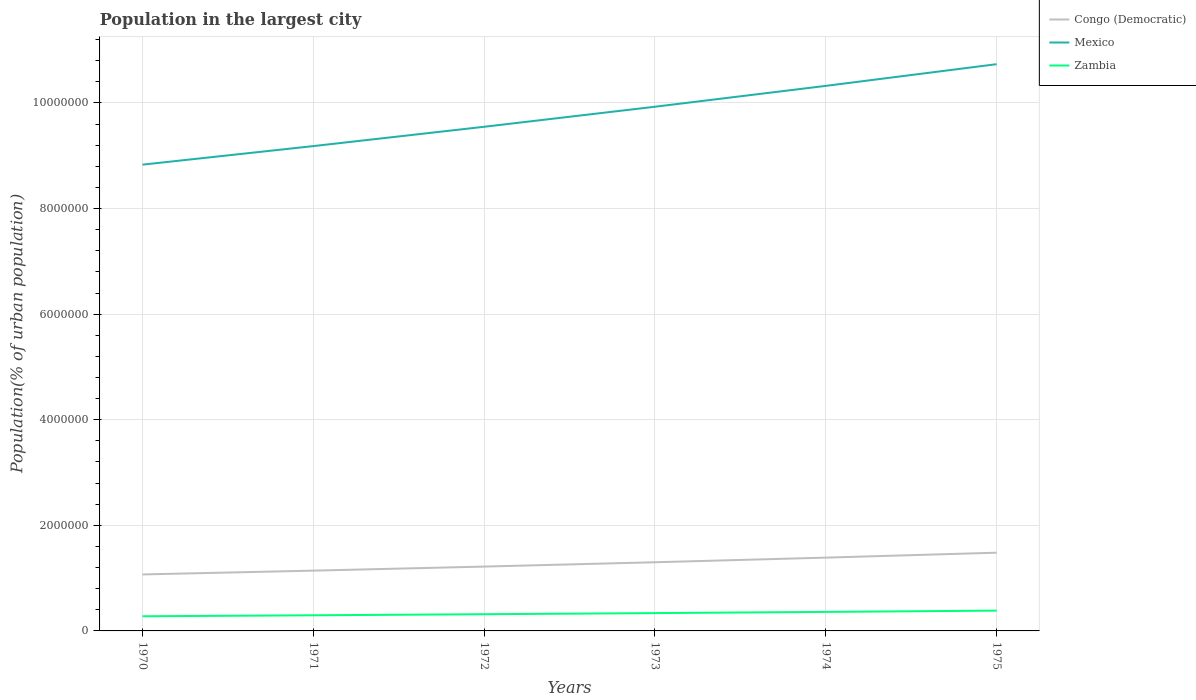Does the line corresponding to Mexico intersect with the line corresponding to Zambia?
Provide a short and direct response. No. Is the number of lines equal to the number of legend labels?
Your answer should be very brief. Yes. Across all years, what is the maximum population in the largest city in Congo (Democratic)?
Offer a terse response. 1.07e+06. In which year was the population in the largest city in Zambia maximum?
Provide a succinct answer. 1970. What is the total population in the largest city in Mexico in the graph?
Ensure brevity in your answer.  -8.06e+05. What is the difference between the highest and the second highest population in the largest city in Mexico?
Your response must be concise. 1.90e+06. What is the difference between the highest and the lowest population in the largest city in Congo (Democratic)?
Keep it short and to the point. 3. Is the population in the largest city in Mexico strictly greater than the population in the largest city in Zambia over the years?
Offer a terse response. No. How many lines are there?
Ensure brevity in your answer.  3. Does the graph contain any zero values?
Provide a short and direct response. No. Where does the legend appear in the graph?
Provide a succinct answer. Top right. How are the legend labels stacked?
Ensure brevity in your answer.  Vertical. What is the title of the graph?
Provide a succinct answer. Population in the largest city. What is the label or title of the X-axis?
Provide a succinct answer. Years. What is the label or title of the Y-axis?
Give a very brief answer. Population(% of urban population). What is the Population(% of urban population) in Congo (Democratic) in 1970?
Make the answer very short. 1.07e+06. What is the Population(% of urban population) of Mexico in 1970?
Your answer should be very brief. 8.83e+06. What is the Population(% of urban population) of Zambia in 1970?
Your response must be concise. 2.78e+05. What is the Population(% of urban population) of Congo (Democratic) in 1971?
Give a very brief answer. 1.14e+06. What is the Population(% of urban population) of Mexico in 1971?
Make the answer very short. 9.18e+06. What is the Population(% of urban population) of Zambia in 1971?
Offer a very short reply. 2.96e+05. What is the Population(% of urban population) of Congo (Democratic) in 1972?
Give a very brief answer. 1.22e+06. What is the Population(% of urban population) in Mexico in 1972?
Your answer should be very brief. 9.55e+06. What is the Population(% of urban population) in Zambia in 1972?
Provide a short and direct response. 3.16e+05. What is the Population(% of urban population) in Congo (Democratic) in 1973?
Keep it short and to the point. 1.30e+06. What is the Population(% of urban population) in Mexico in 1973?
Provide a short and direct response. 9.93e+06. What is the Population(% of urban population) of Zambia in 1973?
Your answer should be very brief. 3.38e+05. What is the Population(% of urban population) in Congo (Democratic) in 1974?
Your answer should be compact. 1.39e+06. What is the Population(% of urban population) in Mexico in 1974?
Make the answer very short. 1.03e+07. What is the Population(% of urban population) in Zambia in 1974?
Offer a terse response. 3.60e+05. What is the Population(% of urban population) in Congo (Democratic) in 1975?
Your response must be concise. 1.48e+06. What is the Population(% of urban population) in Mexico in 1975?
Keep it short and to the point. 1.07e+07. What is the Population(% of urban population) in Zambia in 1975?
Provide a short and direct response. 3.85e+05. Across all years, what is the maximum Population(% of urban population) of Congo (Democratic)?
Provide a succinct answer. 1.48e+06. Across all years, what is the maximum Population(% of urban population) in Mexico?
Your answer should be compact. 1.07e+07. Across all years, what is the maximum Population(% of urban population) in Zambia?
Provide a succinct answer. 3.85e+05. Across all years, what is the minimum Population(% of urban population) of Congo (Democratic)?
Provide a short and direct response. 1.07e+06. Across all years, what is the minimum Population(% of urban population) in Mexico?
Your response must be concise. 8.83e+06. Across all years, what is the minimum Population(% of urban population) in Zambia?
Provide a succinct answer. 2.78e+05. What is the total Population(% of urban population) in Congo (Democratic) in the graph?
Keep it short and to the point. 7.60e+06. What is the total Population(% of urban population) in Mexico in the graph?
Your answer should be compact. 5.85e+07. What is the total Population(% of urban population) of Zambia in the graph?
Provide a succinct answer. 1.97e+06. What is the difference between the Population(% of urban population) in Congo (Democratic) in 1970 and that in 1971?
Ensure brevity in your answer.  -7.20e+04. What is the difference between the Population(% of urban population) in Mexico in 1970 and that in 1971?
Keep it short and to the point. -3.51e+05. What is the difference between the Population(% of urban population) in Zambia in 1970 and that in 1971?
Provide a succinct answer. -1.87e+04. What is the difference between the Population(% of urban population) in Congo (Democratic) in 1970 and that in 1972?
Ensure brevity in your answer.  -1.49e+05. What is the difference between the Population(% of urban population) of Mexico in 1970 and that in 1972?
Provide a short and direct response. -7.17e+05. What is the difference between the Population(% of urban population) in Zambia in 1970 and that in 1972?
Make the answer very short. -3.87e+04. What is the difference between the Population(% of urban population) in Congo (Democratic) in 1970 and that in 1973?
Ensure brevity in your answer.  -2.31e+05. What is the difference between the Population(% of urban population) of Mexico in 1970 and that in 1973?
Offer a very short reply. -1.10e+06. What is the difference between the Population(% of urban population) of Zambia in 1970 and that in 1973?
Keep it short and to the point. -6.00e+04. What is the difference between the Population(% of urban population) in Congo (Democratic) in 1970 and that in 1974?
Ensure brevity in your answer.  -3.19e+05. What is the difference between the Population(% of urban population) of Mexico in 1970 and that in 1974?
Offer a very short reply. -1.49e+06. What is the difference between the Population(% of urban population) in Zambia in 1970 and that in 1974?
Ensure brevity in your answer.  -8.27e+04. What is the difference between the Population(% of urban population) in Congo (Democratic) in 1970 and that in 1975?
Offer a very short reply. -4.12e+05. What is the difference between the Population(% of urban population) in Mexico in 1970 and that in 1975?
Make the answer very short. -1.90e+06. What is the difference between the Population(% of urban population) in Zambia in 1970 and that in 1975?
Your answer should be very brief. -1.07e+05. What is the difference between the Population(% of urban population) of Congo (Democratic) in 1971 and that in 1972?
Your response must be concise. -7.70e+04. What is the difference between the Population(% of urban population) in Mexico in 1971 and that in 1972?
Give a very brief answer. -3.66e+05. What is the difference between the Population(% of urban population) of Zambia in 1971 and that in 1972?
Offer a terse response. -2.00e+04. What is the difference between the Population(% of urban population) of Congo (Democratic) in 1971 and that in 1973?
Make the answer very short. -1.59e+05. What is the difference between the Population(% of urban population) of Mexico in 1971 and that in 1973?
Your answer should be very brief. -7.45e+05. What is the difference between the Population(% of urban population) of Zambia in 1971 and that in 1973?
Provide a short and direct response. -4.13e+04. What is the difference between the Population(% of urban population) in Congo (Democratic) in 1971 and that in 1974?
Offer a very short reply. -2.47e+05. What is the difference between the Population(% of urban population) of Mexico in 1971 and that in 1974?
Offer a very short reply. -1.14e+06. What is the difference between the Population(% of urban population) of Zambia in 1971 and that in 1974?
Provide a short and direct response. -6.40e+04. What is the difference between the Population(% of urban population) in Congo (Democratic) in 1971 and that in 1975?
Offer a terse response. -3.40e+05. What is the difference between the Population(% of urban population) of Mexico in 1971 and that in 1975?
Give a very brief answer. -1.55e+06. What is the difference between the Population(% of urban population) in Zambia in 1971 and that in 1975?
Provide a short and direct response. -8.83e+04. What is the difference between the Population(% of urban population) in Congo (Democratic) in 1972 and that in 1973?
Your answer should be compact. -8.20e+04. What is the difference between the Population(% of urban population) in Mexico in 1972 and that in 1973?
Make the answer very short. -3.79e+05. What is the difference between the Population(% of urban population) in Zambia in 1972 and that in 1973?
Your response must be concise. -2.13e+04. What is the difference between the Population(% of urban population) in Congo (Democratic) in 1972 and that in 1974?
Provide a short and direct response. -1.70e+05. What is the difference between the Population(% of urban population) of Mexico in 1972 and that in 1974?
Offer a terse response. -7.75e+05. What is the difference between the Population(% of urban population) of Zambia in 1972 and that in 1974?
Give a very brief answer. -4.40e+04. What is the difference between the Population(% of urban population) of Congo (Democratic) in 1972 and that in 1975?
Your answer should be compact. -2.63e+05. What is the difference between the Population(% of urban population) in Mexico in 1972 and that in 1975?
Your answer should be very brief. -1.19e+06. What is the difference between the Population(% of urban population) of Zambia in 1972 and that in 1975?
Offer a terse response. -6.83e+04. What is the difference between the Population(% of urban population) of Congo (Democratic) in 1973 and that in 1974?
Offer a terse response. -8.76e+04. What is the difference between the Population(% of urban population) in Mexico in 1973 and that in 1974?
Ensure brevity in your answer.  -3.95e+05. What is the difference between the Population(% of urban population) in Zambia in 1973 and that in 1974?
Your answer should be compact. -2.28e+04. What is the difference between the Population(% of urban population) of Congo (Democratic) in 1973 and that in 1975?
Ensure brevity in your answer.  -1.81e+05. What is the difference between the Population(% of urban population) in Mexico in 1973 and that in 1975?
Your answer should be compact. -8.06e+05. What is the difference between the Population(% of urban population) of Zambia in 1973 and that in 1975?
Give a very brief answer. -4.70e+04. What is the difference between the Population(% of urban population) in Congo (Democratic) in 1974 and that in 1975?
Ensure brevity in your answer.  -9.35e+04. What is the difference between the Population(% of urban population) in Mexico in 1974 and that in 1975?
Make the answer very short. -4.11e+05. What is the difference between the Population(% of urban population) of Zambia in 1974 and that in 1975?
Keep it short and to the point. -2.43e+04. What is the difference between the Population(% of urban population) of Congo (Democratic) in 1970 and the Population(% of urban population) of Mexico in 1971?
Your response must be concise. -8.11e+06. What is the difference between the Population(% of urban population) of Congo (Democratic) in 1970 and the Population(% of urban population) of Zambia in 1971?
Give a very brief answer. 7.73e+05. What is the difference between the Population(% of urban population) in Mexico in 1970 and the Population(% of urban population) in Zambia in 1971?
Your response must be concise. 8.53e+06. What is the difference between the Population(% of urban population) of Congo (Democratic) in 1970 and the Population(% of urban population) of Mexico in 1972?
Keep it short and to the point. -8.48e+06. What is the difference between the Population(% of urban population) of Congo (Democratic) in 1970 and the Population(% of urban population) of Zambia in 1972?
Give a very brief answer. 7.53e+05. What is the difference between the Population(% of urban population) of Mexico in 1970 and the Population(% of urban population) of Zambia in 1972?
Your answer should be very brief. 8.51e+06. What is the difference between the Population(% of urban population) of Congo (Democratic) in 1970 and the Population(% of urban population) of Mexico in 1973?
Keep it short and to the point. -8.86e+06. What is the difference between the Population(% of urban population) of Congo (Democratic) in 1970 and the Population(% of urban population) of Zambia in 1973?
Provide a succinct answer. 7.32e+05. What is the difference between the Population(% of urban population) in Mexico in 1970 and the Population(% of urban population) in Zambia in 1973?
Your response must be concise. 8.49e+06. What is the difference between the Population(% of urban population) of Congo (Democratic) in 1970 and the Population(% of urban population) of Mexico in 1974?
Your answer should be compact. -9.25e+06. What is the difference between the Population(% of urban population) of Congo (Democratic) in 1970 and the Population(% of urban population) of Zambia in 1974?
Make the answer very short. 7.09e+05. What is the difference between the Population(% of urban population) in Mexico in 1970 and the Population(% of urban population) in Zambia in 1974?
Make the answer very short. 8.47e+06. What is the difference between the Population(% of urban population) in Congo (Democratic) in 1970 and the Population(% of urban population) in Mexico in 1975?
Make the answer very short. -9.66e+06. What is the difference between the Population(% of urban population) in Congo (Democratic) in 1970 and the Population(% of urban population) in Zambia in 1975?
Provide a succinct answer. 6.85e+05. What is the difference between the Population(% of urban population) of Mexico in 1970 and the Population(% of urban population) of Zambia in 1975?
Keep it short and to the point. 8.45e+06. What is the difference between the Population(% of urban population) in Congo (Democratic) in 1971 and the Population(% of urban population) in Mexico in 1972?
Provide a succinct answer. -8.41e+06. What is the difference between the Population(% of urban population) of Congo (Democratic) in 1971 and the Population(% of urban population) of Zambia in 1972?
Your answer should be compact. 8.26e+05. What is the difference between the Population(% of urban population) of Mexico in 1971 and the Population(% of urban population) of Zambia in 1972?
Your answer should be compact. 8.87e+06. What is the difference between the Population(% of urban population) in Congo (Democratic) in 1971 and the Population(% of urban population) in Mexico in 1973?
Offer a terse response. -8.79e+06. What is the difference between the Population(% of urban population) of Congo (Democratic) in 1971 and the Population(% of urban population) of Zambia in 1973?
Offer a very short reply. 8.04e+05. What is the difference between the Population(% of urban population) of Mexico in 1971 and the Population(% of urban population) of Zambia in 1973?
Provide a short and direct response. 8.84e+06. What is the difference between the Population(% of urban population) in Congo (Democratic) in 1971 and the Population(% of urban population) in Mexico in 1974?
Keep it short and to the point. -9.18e+06. What is the difference between the Population(% of urban population) in Congo (Democratic) in 1971 and the Population(% of urban population) in Zambia in 1974?
Your answer should be compact. 7.81e+05. What is the difference between the Population(% of urban population) in Mexico in 1971 and the Population(% of urban population) in Zambia in 1974?
Provide a short and direct response. 8.82e+06. What is the difference between the Population(% of urban population) in Congo (Democratic) in 1971 and the Population(% of urban population) in Mexico in 1975?
Your answer should be compact. -9.59e+06. What is the difference between the Population(% of urban population) of Congo (Democratic) in 1971 and the Population(% of urban population) of Zambia in 1975?
Keep it short and to the point. 7.57e+05. What is the difference between the Population(% of urban population) in Mexico in 1971 and the Population(% of urban population) in Zambia in 1975?
Offer a very short reply. 8.80e+06. What is the difference between the Population(% of urban population) of Congo (Democratic) in 1972 and the Population(% of urban population) of Mexico in 1973?
Your response must be concise. -8.71e+06. What is the difference between the Population(% of urban population) in Congo (Democratic) in 1972 and the Population(% of urban population) in Zambia in 1973?
Offer a very short reply. 8.81e+05. What is the difference between the Population(% of urban population) of Mexico in 1972 and the Population(% of urban population) of Zambia in 1973?
Ensure brevity in your answer.  9.21e+06. What is the difference between the Population(% of urban population) of Congo (Democratic) in 1972 and the Population(% of urban population) of Mexico in 1974?
Offer a terse response. -9.10e+06. What is the difference between the Population(% of urban population) of Congo (Democratic) in 1972 and the Population(% of urban population) of Zambia in 1974?
Your answer should be compact. 8.58e+05. What is the difference between the Population(% of urban population) in Mexico in 1972 and the Population(% of urban population) in Zambia in 1974?
Provide a succinct answer. 9.19e+06. What is the difference between the Population(% of urban population) of Congo (Democratic) in 1972 and the Population(% of urban population) of Mexico in 1975?
Your answer should be compact. -9.52e+06. What is the difference between the Population(% of urban population) of Congo (Democratic) in 1972 and the Population(% of urban population) of Zambia in 1975?
Ensure brevity in your answer.  8.34e+05. What is the difference between the Population(% of urban population) in Mexico in 1972 and the Population(% of urban population) in Zambia in 1975?
Your response must be concise. 9.16e+06. What is the difference between the Population(% of urban population) in Congo (Democratic) in 1973 and the Population(% of urban population) in Mexico in 1974?
Give a very brief answer. -9.02e+06. What is the difference between the Population(% of urban population) in Congo (Democratic) in 1973 and the Population(% of urban population) in Zambia in 1974?
Keep it short and to the point. 9.40e+05. What is the difference between the Population(% of urban population) in Mexico in 1973 and the Population(% of urban population) in Zambia in 1974?
Provide a short and direct response. 9.57e+06. What is the difference between the Population(% of urban population) of Congo (Democratic) in 1973 and the Population(% of urban population) of Mexico in 1975?
Provide a short and direct response. -9.43e+06. What is the difference between the Population(% of urban population) of Congo (Democratic) in 1973 and the Population(% of urban population) of Zambia in 1975?
Provide a short and direct response. 9.16e+05. What is the difference between the Population(% of urban population) of Mexico in 1973 and the Population(% of urban population) of Zambia in 1975?
Keep it short and to the point. 9.54e+06. What is the difference between the Population(% of urban population) in Congo (Democratic) in 1974 and the Population(% of urban population) in Mexico in 1975?
Your response must be concise. -9.35e+06. What is the difference between the Population(% of urban population) of Congo (Democratic) in 1974 and the Population(% of urban population) of Zambia in 1975?
Give a very brief answer. 1.00e+06. What is the difference between the Population(% of urban population) in Mexico in 1974 and the Population(% of urban population) in Zambia in 1975?
Keep it short and to the point. 9.94e+06. What is the average Population(% of urban population) of Congo (Democratic) per year?
Your answer should be very brief. 1.27e+06. What is the average Population(% of urban population) in Mexico per year?
Your answer should be very brief. 9.76e+06. What is the average Population(% of urban population) in Zambia per year?
Offer a terse response. 3.29e+05. In the year 1970, what is the difference between the Population(% of urban population) of Congo (Democratic) and Population(% of urban population) of Mexico?
Provide a succinct answer. -7.76e+06. In the year 1970, what is the difference between the Population(% of urban population) in Congo (Democratic) and Population(% of urban population) in Zambia?
Ensure brevity in your answer.  7.92e+05. In the year 1970, what is the difference between the Population(% of urban population) of Mexico and Population(% of urban population) of Zambia?
Make the answer very short. 8.55e+06. In the year 1971, what is the difference between the Population(% of urban population) of Congo (Democratic) and Population(% of urban population) of Mexico?
Your answer should be very brief. -8.04e+06. In the year 1971, what is the difference between the Population(% of urban population) in Congo (Democratic) and Population(% of urban population) in Zambia?
Keep it short and to the point. 8.46e+05. In the year 1971, what is the difference between the Population(% of urban population) in Mexico and Population(% of urban population) in Zambia?
Provide a short and direct response. 8.89e+06. In the year 1972, what is the difference between the Population(% of urban population) of Congo (Democratic) and Population(% of urban population) of Mexico?
Provide a succinct answer. -8.33e+06. In the year 1972, what is the difference between the Population(% of urban population) of Congo (Democratic) and Population(% of urban population) of Zambia?
Your response must be concise. 9.03e+05. In the year 1972, what is the difference between the Population(% of urban population) of Mexico and Population(% of urban population) of Zambia?
Make the answer very short. 9.23e+06. In the year 1973, what is the difference between the Population(% of urban population) in Congo (Democratic) and Population(% of urban population) in Mexico?
Provide a short and direct response. -8.63e+06. In the year 1973, what is the difference between the Population(% of urban population) of Congo (Democratic) and Population(% of urban population) of Zambia?
Provide a succinct answer. 9.63e+05. In the year 1973, what is the difference between the Population(% of urban population) of Mexico and Population(% of urban population) of Zambia?
Give a very brief answer. 9.59e+06. In the year 1974, what is the difference between the Population(% of urban population) in Congo (Democratic) and Population(% of urban population) in Mexico?
Provide a succinct answer. -8.93e+06. In the year 1974, what is the difference between the Population(% of urban population) in Congo (Democratic) and Population(% of urban population) in Zambia?
Provide a succinct answer. 1.03e+06. In the year 1974, what is the difference between the Population(% of urban population) of Mexico and Population(% of urban population) of Zambia?
Offer a very short reply. 9.96e+06. In the year 1975, what is the difference between the Population(% of urban population) of Congo (Democratic) and Population(% of urban population) of Mexico?
Your answer should be very brief. -9.25e+06. In the year 1975, what is the difference between the Population(% of urban population) in Congo (Democratic) and Population(% of urban population) in Zambia?
Keep it short and to the point. 1.10e+06. In the year 1975, what is the difference between the Population(% of urban population) in Mexico and Population(% of urban population) in Zambia?
Make the answer very short. 1.03e+07. What is the ratio of the Population(% of urban population) of Congo (Democratic) in 1970 to that in 1971?
Ensure brevity in your answer.  0.94. What is the ratio of the Population(% of urban population) in Mexico in 1970 to that in 1971?
Offer a very short reply. 0.96. What is the ratio of the Population(% of urban population) in Zambia in 1970 to that in 1971?
Provide a succinct answer. 0.94. What is the ratio of the Population(% of urban population) of Congo (Democratic) in 1970 to that in 1972?
Give a very brief answer. 0.88. What is the ratio of the Population(% of urban population) of Mexico in 1970 to that in 1972?
Your response must be concise. 0.92. What is the ratio of the Population(% of urban population) of Zambia in 1970 to that in 1972?
Your answer should be very brief. 0.88. What is the ratio of the Population(% of urban population) of Congo (Democratic) in 1970 to that in 1973?
Provide a short and direct response. 0.82. What is the ratio of the Population(% of urban population) of Mexico in 1970 to that in 1973?
Provide a short and direct response. 0.89. What is the ratio of the Population(% of urban population) of Zambia in 1970 to that in 1973?
Your answer should be compact. 0.82. What is the ratio of the Population(% of urban population) of Congo (Democratic) in 1970 to that in 1974?
Provide a short and direct response. 0.77. What is the ratio of the Population(% of urban population) of Mexico in 1970 to that in 1974?
Give a very brief answer. 0.86. What is the ratio of the Population(% of urban population) of Zambia in 1970 to that in 1974?
Your response must be concise. 0.77. What is the ratio of the Population(% of urban population) in Congo (Democratic) in 1970 to that in 1975?
Provide a succinct answer. 0.72. What is the ratio of the Population(% of urban population) of Mexico in 1970 to that in 1975?
Your answer should be very brief. 0.82. What is the ratio of the Population(% of urban population) in Zambia in 1970 to that in 1975?
Keep it short and to the point. 0.72. What is the ratio of the Population(% of urban population) in Congo (Democratic) in 1971 to that in 1972?
Provide a short and direct response. 0.94. What is the ratio of the Population(% of urban population) in Mexico in 1971 to that in 1972?
Ensure brevity in your answer.  0.96. What is the ratio of the Population(% of urban population) in Zambia in 1971 to that in 1972?
Give a very brief answer. 0.94. What is the ratio of the Population(% of urban population) of Congo (Democratic) in 1971 to that in 1973?
Your answer should be compact. 0.88. What is the ratio of the Population(% of urban population) in Mexico in 1971 to that in 1973?
Make the answer very short. 0.92. What is the ratio of the Population(% of urban population) of Zambia in 1971 to that in 1973?
Your response must be concise. 0.88. What is the ratio of the Population(% of urban population) of Congo (Democratic) in 1971 to that in 1974?
Provide a succinct answer. 0.82. What is the ratio of the Population(% of urban population) in Mexico in 1971 to that in 1974?
Your answer should be very brief. 0.89. What is the ratio of the Population(% of urban population) in Zambia in 1971 to that in 1974?
Your response must be concise. 0.82. What is the ratio of the Population(% of urban population) of Congo (Democratic) in 1971 to that in 1975?
Offer a terse response. 0.77. What is the ratio of the Population(% of urban population) in Mexico in 1971 to that in 1975?
Offer a very short reply. 0.86. What is the ratio of the Population(% of urban population) in Zambia in 1971 to that in 1975?
Ensure brevity in your answer.  0.77. What is the ratio of the Population(% of urban population) of Congo (Democratic) in 1972 to that in 1973?
Offer a terse response. 0.94. What is the ratio of the Population(% of urban population) of Mexico in 1972 to that in 1973?
Offer a very short reply. 0.96. What is the ratio of the Population(% of urban population) of Zambia in 1972 to that in 1973?
Ensure brevity in your answer.  0.94. What is the ratio of the Population(% of urban population) of Congo (Democratic) in 1972 to that in 1974?
Provide a succinct answer. 0.88. What is the ratio of the Population(% of urban population) of Mexico in 1972 to that in 1974?
Make the answer very short. 0.93. What is the ratio of the Population(% of urban population) in Zambia in 1972 to that in 1974?
Provide a short and direct response. 0.88. What is the ratio of the Population(% of urban population) of Congo (Democratic) in 1972 to that in 1975?
Provide a short and direct response. 0.82. What is the ratio of the Population(% of urban population) of Mexico in 1972 to that in 1975?
Your response must be concise. 0.89. What is the ratio of the Population(% of urban population) of Zambia in 1972 to that in 1975?
Your answer should be compact. 0.82. What is the ratio of the Population(% of urban population) of Congo (Democratic) in 1973 to that in 1974?
Keep it short and to the point. 0.94. What is the ratio of the Population(% of urban population) in Mexico in 1973 to that in 1974?
Provide a succinct answer. 0.96. What is the ratio of the Population(% of urban population) of Zambia in 1973 to that in 1974?
Provide a short and direct response. 0.94. What is the ratio of the Population(% of urban population) in Congo (Democratic) in 1973 to that in 1975?
Your answer should be very brief. 0.88. What is the ratio of the Population(% of urban population) of Mexico in 1973 to that in 1975?
Your answer should be very brief. 0.92. What is the ratio of the Population(% of urban population) in Zambia in 1973 to that in 1975?
Ensure brevity in your answer.  0.88. What is the ratio of the Population(% of urban population) in Congo (Democratic) in 1974 to that in 1975?
Your answer should be compact. 0.94. What is the ratio of the Population(% of urban population) in Mexico in 1974 to that in 1975?
Provide a short and direct response. 0.96. What is the ratio of the Population(% of urban population) in Zambia in 1974 to that in 1975?
Keep it short and to the point. 0.94. What is the difference between the highest and the second highest Population(% of urban population) of Congo (Democratic)?
Ensure brevity in your answer.  9.35e+04. What is the difference between the highest and the second highest Population(% of urban population) of Mexico?
Make the answer very short. 4.11e+05. What is the difference between the highest and the second highest Population(% of urban population) in Zambia?
Provide a short and direct response. 2.43e+04. What is the difference between the highest and the lowest Population(% of urban population) in Congo (Democratic)?
Give a very brief answer. 4.12e+05. What is the difference between the highest and the lowest Population(% of urban population) of Mexico?
Keep it short and to the point. 1.90e+06. What is the difference between the highest and the lowest Population(% of urban population) of Zambia?
Make the answer very short. 1.07e+05. 